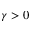Convert formula to latex. <formula><loc_0><loc_0><loc_500><loc_500>\gamma > 0</formula> 